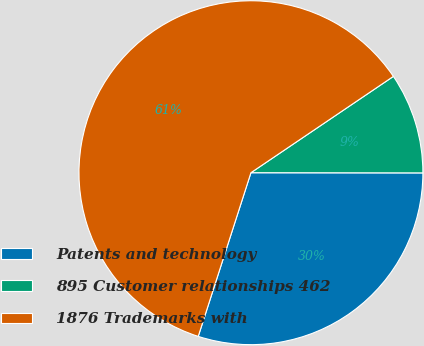Convert chart to OTSL. <chart><loc_0><loc_0><loc_500><loc_500><pie_chart><fcel>Patents and technology<fcel>895 Customer relationships 462<fcel>1876 Trademarks with<nl><fcel>29.94%<fcel>9.48%<fcel>60.58%<nl></chart> 